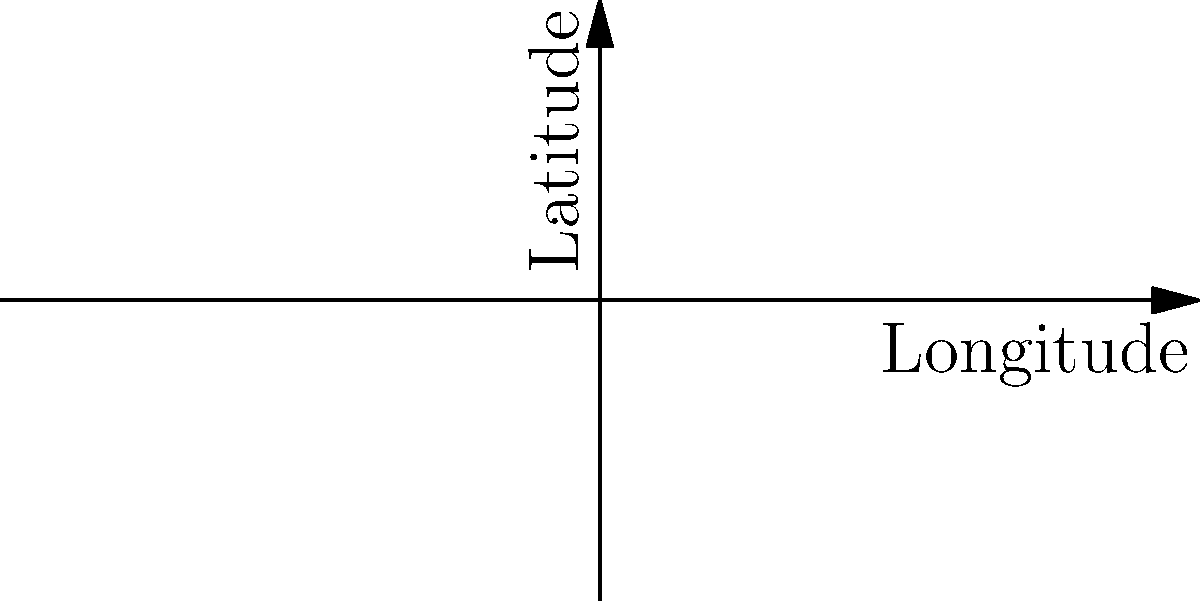Based on the world map showing the locations of famous magicians' performances, which city is represented by the point closest to the equator (0° latitude)? To determine which city is closest to the equator, we need to compare the absolute values of the latitudes for each city:

1. New York: |40.7128°| = 40.7128°
2. London: |51.5074°| = 51.5074°
3. Paris: |48.8566°| = 48.8566°
4. Tokyo: |35.6762°| = 35.6762°
5. Sydney: |-33.8688°| = 33.8688°

The city with the smallest absolute latitude value is closest to the equator. Comparing these values, we can see that Sydney has the smallest absolute latitude (33.8688°).

Therefore, Sydney is the city closest to the equator among the given options.
Answer: Sydney 